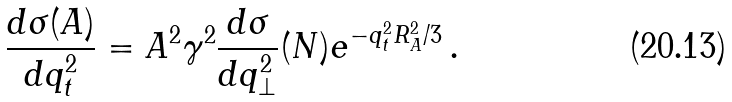<formula> <loc_0><loc_0><loc_500><loc_500>\frac { d \sigma ( A ) } { d q ^ { 2 } _ { t } } = A ^ { 2 } \gamma ^ { 2 } \frac { d \sigma } { d q ^ { 2 } _ { \perp } } ( N ) e ^ { - q ^ { 2 } _ { t } R ^ { 2 } _ { A } / 3 } \, .</formula> 